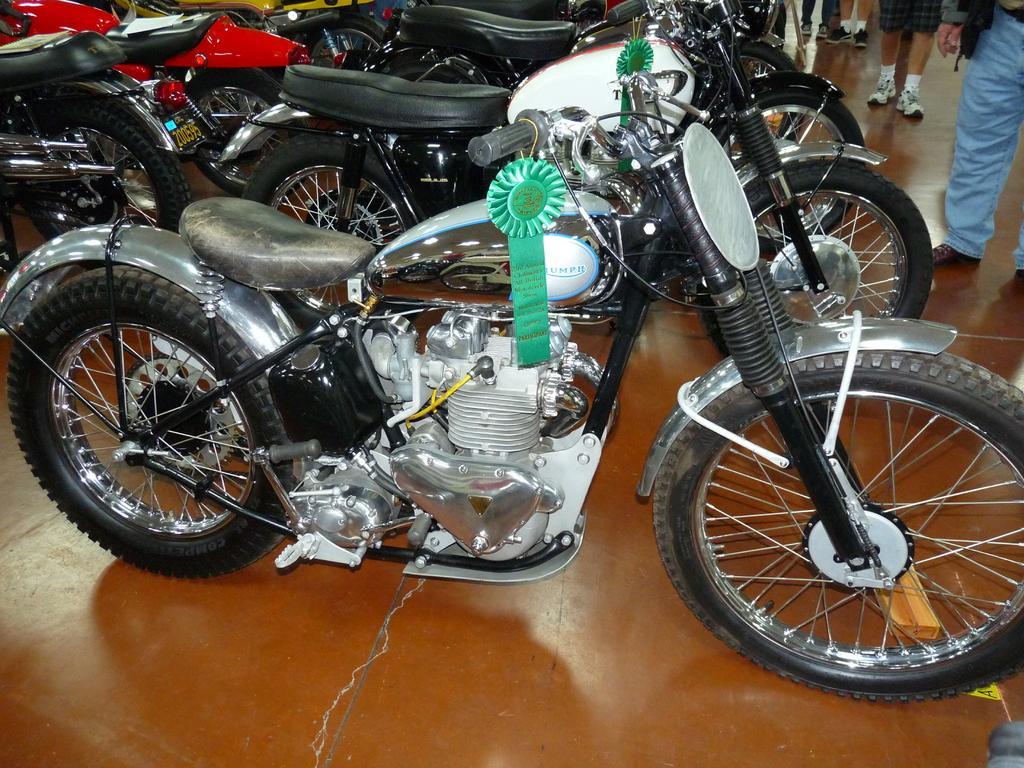Could you give a brief overview of what you see in this image? In this picture we can see group of people and few motorcycles. 